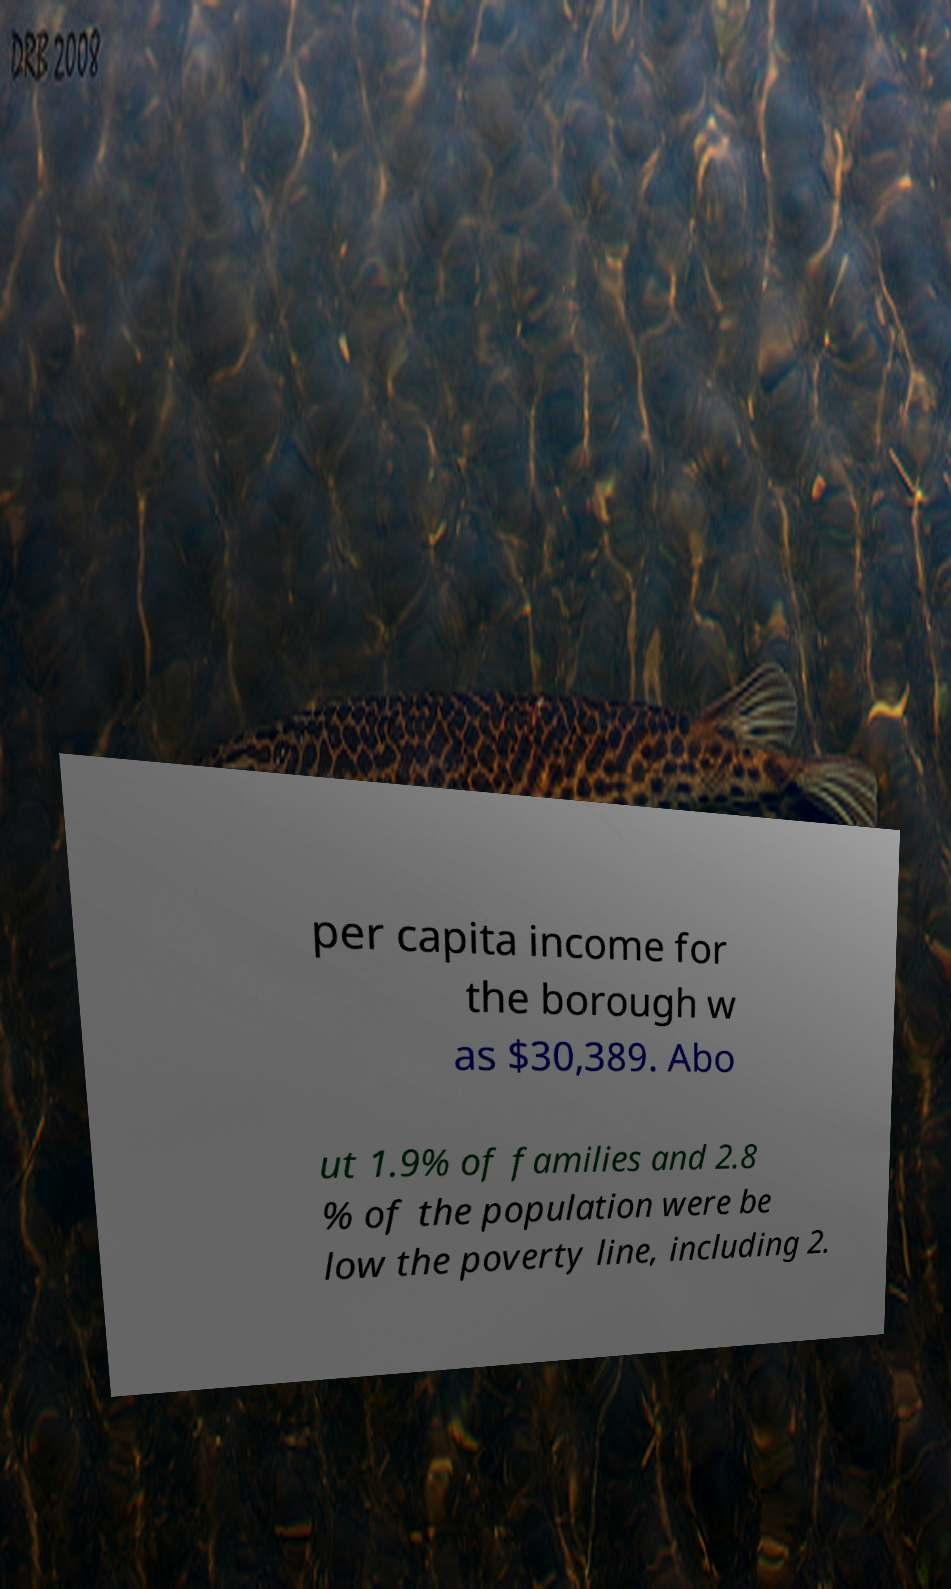Could you assist in decoding the text presented in this image and type it out clearly? per capita income for the borough w as $30,389. Abo ut 1.9% of families and 2.8 % of the population were be low the poverty line, including 2. 